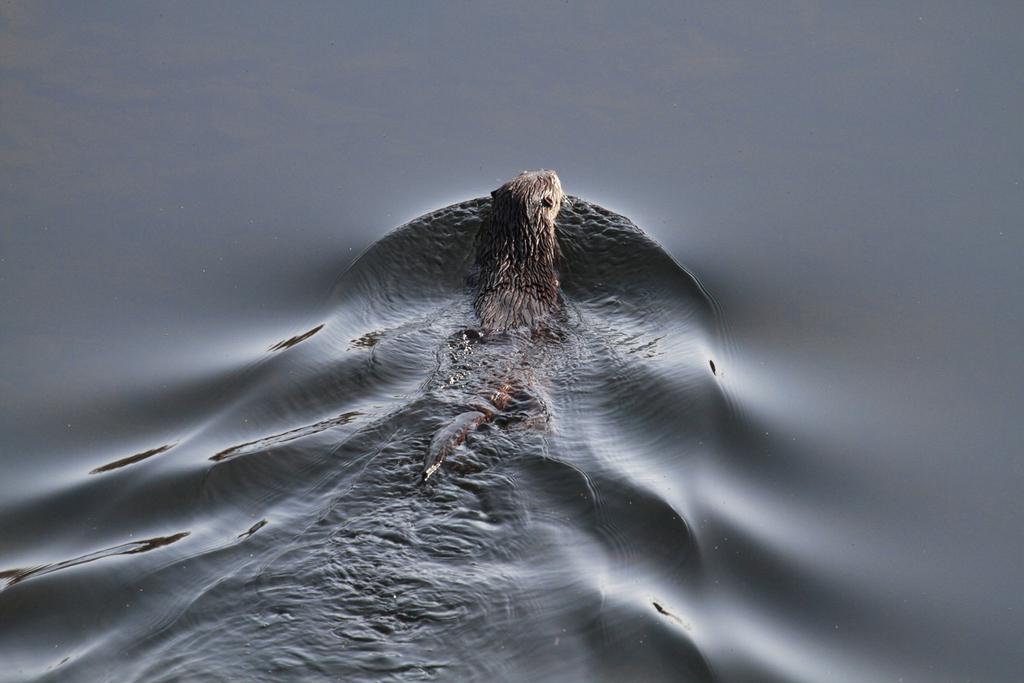In one or two sentences, can you explain what this image depicts? In the image there is an animal inside the water. 